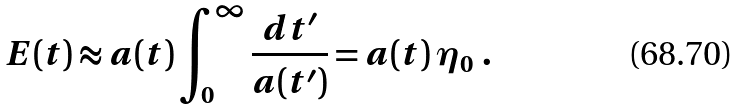<formula> <loc_0><loc_0><loc_500><loc_500>E ( t ) \approx a ( t ) \int ^ { \infty } _ { 0 } \frac { d t ^ { \prime } } { a ( t ^ { \prime } ) } = a ( t ) \, \eta _ { 0 } \ .</formula> 